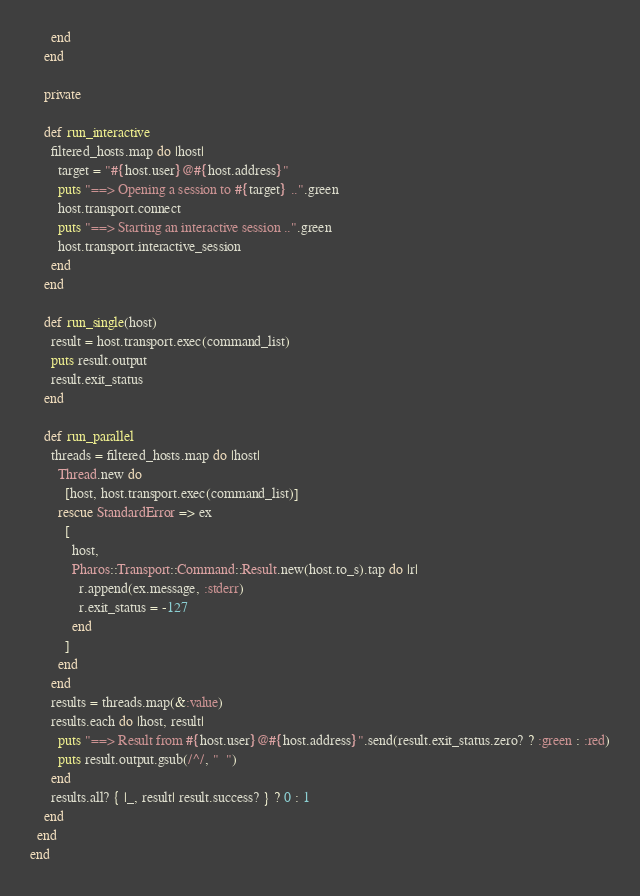Convert code to text. <code><loc_0><loc_0><loc_500><loc_500><_Ruby_>      end
    end

    private

    def run_interactive
      filtered_hosts.map do |host|
        target = "#{host.user}@#{host.address}"
        puts "==> Opening a session to #{target} ..".green
        host.transport.connect
        puts "==> Starting an interactive session ..".green
        host.transport.interactive_session
      end
    end

    def run_single(host)
      result = host.transport.exec(command_list)
      puts result.output
      result.exit_status
    end

    def run_parallel
      threads = filtered_hosts.map do |host|
        Thread.new do
          [host, host.transport.exec(command_list)]
        rescue StandardError => ex
          [
            host,
            Pharos::Transport::Command::Result.new(host.to_s).tap do |r|
              r.append(ex.message, :stderr)
              r.exit_status = -127
            end
          ]
        end
      end
      results = threads.map(&:value)
      results.each do |host, result|
        puts "==> Result from #{host.user}@#{host.address}".send(result.exit_status.zero? ? :green : :red)
        puts result.output.gsub(/^/, "  ")
      end
      results.all? { |_, result| result.success? } ? 0 : 1
    end
  end
end
</code> 